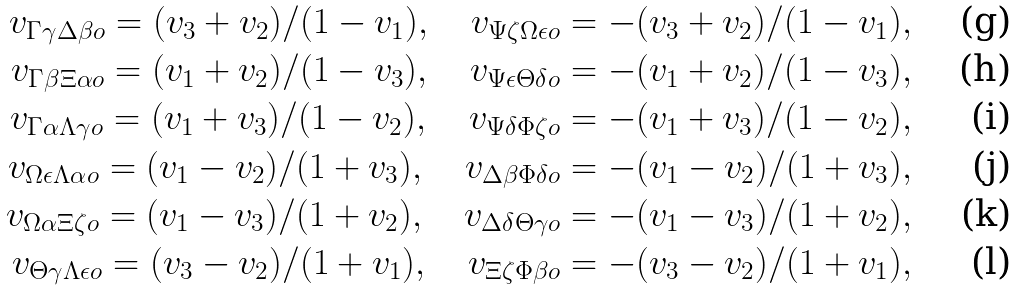Convert formula to latex. <formula><loc_0><loc_0><loc_500><loc_500>v _ { \Gamma \gamma \Delta \beta o } = ( v _ { 3 } + v _ { 2 } ) / ( 1 - v _ { 1 } ) , \quad v _ { \Psi \zeta \Omega \epsilon o } = - ( v _ { 3 } + v _ { 2 } ) / ( 1 - v _ { 1 } ) , \\ v _ { \Gamma \beta \Xi \alpha o } = ( v _ { 1 } + v _ { 2 } ) / ( 1 - v _ { 3 } ) , \quad v _ { \Psi \epsilon \Theta \delta o } = - ( v _ { 1 } + v _ { 2 } ) / ( 1 - v _ { 3 } ) , \\ v _ { \Gamma \alpha \Lambda \gamma o } = ( v _ { 1 } + v _ { 3 } ) / ( 1 - v _ { 2 } ) , \quad v _ { \Psi \delta \Phi \zeta o } = - ( v _ { 1 } + v _ { 3 } ) / ( 1 - v _ { 2 } ) , \\ v _ { \Omega \epsilon \Lambda \alpha o } = ( v _ { 1 } - v _ { 2 } ) / ( 1 + v _ { 3 } ) , \quad v _ { \Delta \beta \Phi \delta o } = - ( v _ { 1 } - v _ { 2 } ) / ( 1 + v _ { 3 } ) , \\ v _ { \Omega \alpha \Xi \zeta o } = ( v _ { 1 } - v _ { 3 } ) / ( 1 + v _ { 2 } ) , \quad v _ { \Delta \delta \Theta \gamma o } = - ( v _ { 1 } - v _ { 3 } ) / ( 1 + v _ { 2 } ) , \\ v _ { \Theta \gamma \Lambda \epsilon o } = ( v _ { 3 } - v _ { 2 } ) / ( 1 + v _ { 1 } ) , \quad v _ { \Xi \zeta \Phi \beta o } = - ( v _ { 3 } - v _ { 2 } ) / ( 1 + v _ { 1 } ) ,</formula> 